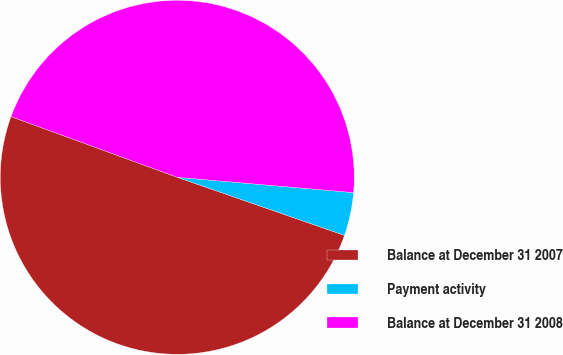Convert chart to OTSL. <chart><loc_0><loc_0><loc_500><loc_500><pie_chart><fcel>Balance at December 31 2007<fcel>Payment activity<fcel>Balance at December 31 2008<nl><fcel>50.25%<fcel>3.94%<fcel>45.81%<nl></chart> 